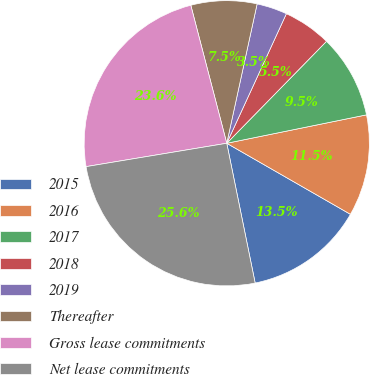Convert chart. <chart><loc_0><loc_0><loc_500><loc_500><pie_chart><fcel>2015<fcel>2016<fcel>2017<fcel>2018<fcel>2019<fcel>Thereafter<fcel>Gross lease commitments<fcel>Net lease commitments<nl><fcel>13.51%<fcel>11.49%<fcel>9.48%<fcel>5.46%<fcel>3.45%<fcel>7.47%<fcel>23.56%<fcel>25.57%<nl></chart> 